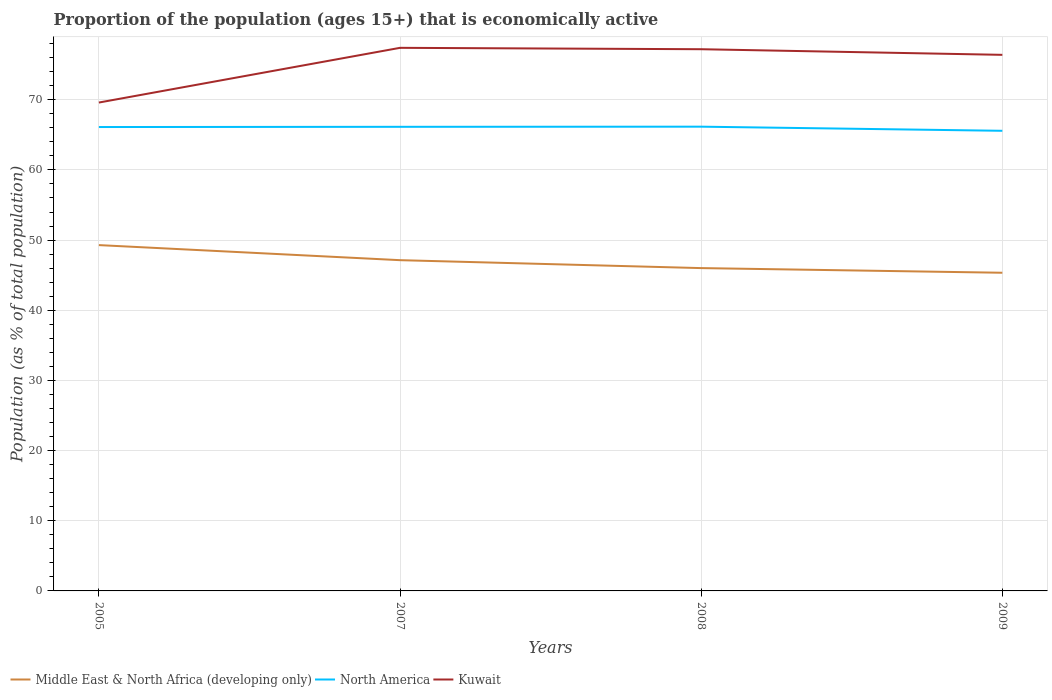How many different coloured lines are there?
Your answer should be very brief. 3. Across all years, what is the maximum proportion of the population that is economically active in Kuwait?
Give a very brief answer. 69.6. What is the total proportion of the population that is economically active in Kuwait in the graph?
Your answer should be very brief. -7.6. What is the difference between the highest and the second highest proportion of the population that is economically active in North America?
Give a very brief answer. 0.59. What is the difference between the highest and the lowest proportion of the population that is economically active in North America?
Offer a terse response. 3. How many lines are there?
Your answer should be compact. 3. How many years are there in the graph?
Offer a terse response. 4. What is the difference between two consecutive major ticks on the Y-axis?
Your response must be concise. 10. Does the graph contain grids?
Your answer should be very brief. Yes. Where does the legend appear in the graph?
Give a very brief answer. Bottom left. How many legend labels are there?
Your answer should be very brief. 3. How are the legend labels stacked?
Your answer should be compact. Horizontal. What is the title of the graph?
Keep it short and to the point. Proportion of the population (ages 15+) that is economically active. Does "Caribbean small states" appear as one of the legend labels in the graph?
Offer a very short reply. No. What is the label or title of the Y-axis?
Offer a very short reply. Population (as % of total population). What is the Population (as % of total population) in Middle East & North Africa (developing only) in 2005?
Make the answer very short. 49.28. What is the Population (as % of total population) in North America in 2005?
Make the answer very short. 66.11. What is the Population (as % of total population) of Kuwait in 2005?
Your answer should be compact. 69.6. What is the Population (as % of total population) in Middle East & North Africa (developing only) in 2007?
Offer a terse response. 47.14. What is the Population (as % of total population) in North America in 2007?
Provide a succinct answer. 66.14. What is the Population (as % of total population) of Kuwait in 2007?
Your answer should be compact. 77.4. What is the Population (as % of total population) of Middle East & North Africa (developing only) in 2008?
Your response must be concise. 46.01. What is the Population (as % of total population) of North America in 2008?
Provide a short and direct response. 66.16. What is the Population (as % of total population) of Kuwait in 2008?
Your answer should be compact. 77.2. What is the Population (as % of total population) of Middle East & North Africa (developing only) in 2009?
Provide a succinct answer. 45.34. What is the Population (as % of total population) in North America in 2009?
Give a very brief answer. 65.57. What is the Population (as % of total population) in Kuwait in 2009?
Offer a very short reply. 76.4. Across all years, what is the maximum Population (as % of total population) of Middle East & North Africa (developing only)?
Your response must be concise. 49.28. Across all years, what is the maximum Population (as % of total population) in North America?
Keep it short and to the point. 66.16. Across all years, what is the maximum Population (as % of total population) in Kuwait?
Provide a succinct answer. 77.4. Across all years, what is the minimum Population (as % of total population) of Middle East & North Africa (developing only)?
Provide a succinct answer. 45.34. Across all years, what is the minimum Population (as % of total population) of North America?
Your response must be concise. 65.57. Across all years, what is the minimum Population (as % of total population) of Kuwait?
Provide a short and direct response. 69.6. What is the total Population (as % of total population) of Middle East & North Africa (developing only) in the graph?
Make the answer very short. 187.77. What is the total Population (as % of total population) in North America in the graph?
Keep it short and to the point. 263.99. What is the total Population (as % of total population) of Kuwait in the graph?
Offer a very short reply. 300.6. What is the difference between the Population (as % of total population) in Middle East & North Africa (developing only) in 2005 and that in 2007?
Offer a terse response. 2.15. What is the difference between the Population (as % of total population) in North America in 2005 and that in 2007?
Make the answer very short. -0.03. What is the difference between the Population (as % of total population) of Middle East & North Africa (developing only) in 2005 and that in 2008?
Ensure brevity in your answer.  3.28. What is the difference between the Population (as % of total population) in North America in 2005 and that in 2008?
Offer a very short reply. -0.05. What is the difference between the Population (as % of total population) of Middle East & North Africa (developing only) in 2005 and that in 2009?
Your answer should be very brief. 3.94. What is the difference between the Population (as % of total population) in North America in 2005 and that in 2009?
Ensure brevity in your answer.  0.54. What is the difference between the Population (as % of total population) of Kuwait in 2005 and that in 2009?
Provide a short and direct response. -6.8. What is the difference between the Population (as % of total population) of Middle East & North Africa (developing only) in 2007 and that in 2008?
Give a very brief answer. 1.13. What is the difference between the Population (as % of total population) in North America in 2007 and that in 2008?
Provide a short and direct response. -0.02. What is the difference between the Population (as % of total population) in Kuwait in 2007 and that in 2008?
Your answer should be very brief. 0.2. What is the difference between the Population (as % of total population) in Middle East & North Africa (developing only) in 2007 and that in 2009?
Provide a succinct answer. 1.79. What is the difference between the Population (as % of total population) in North America in 2007 and that in 2009?
Offer a very short reply. 0.57. What is the difference between the Population (as % of total population) in Middle East & North Africa (developing only) in 2008 and that in 2009?
Your answer should be very brief. 0.66. What is the difference between the Population (as % of total population) in North America in 2008 and that in 2009?
Provide a short and direct response. 0.59. What is the difference between the Population (as % of total population) of Middle East & North Africa (developing only) in 2005 and the Population (as % of total population) of North America in 2007?
Offer a very short reply. -16.86. What is the difference between the Population (as % of total population) in Middle East & North Africa (developing only) in 2005 and the Population (as % of total population) in Kuwait in 2007?
Make the answer very short. -28.12. What is the difference between the Population (as % of total population) in North America in 2005 and the Population (as % of total population) in Kuwait in 2007?
Offer a very short reply. -11.29. What is the difference between the Population (as % of total population) in Middle East & North Africa (developing only) in 2005 and the Population (as % of total population) in North America in 2008?
Your answer should be compact. -16.88. What is the difference between the Population (as % of total population) in Middle East & North Africa (developing only) in 2005 and the Population (as % of total population) in Kuwait in 2008?
Your answer should be very brief. -27.92. What is the difference between the Population (as % of total population) of North America in 2005 and the Population (as % of total population) of Kuwait in 2008?
Your answer should be very brief. -11.09. What is the difference between the Population (as % of total population) of Middle East & North Africa (developing only) in 2005 and the Population (as % of total population) of North America in 2009?
Keep it short and to the point. -16.29. What is the difference between the Population (as % of total population) in Middle East & North Africa (developing only) in 2005 and the Population (as % of total population) in Kuwait in 2009?
Provide a short and direct response. -27.12. What is the difference between the Population (as % of total population) of North America in 2005 and the Population (as % of total population) of Kuwait in 2009?
Provide a succinct answer. -10.29. What is the difference between the Population (as % of total population) in Middle East & North Africa (developing only) in 2007 and the Population (as % of total population) in North America in 2008?
Give a very brief answer. -19.03. What is the difference between the Population (as % of total population) of Middle East & North Africa (developing only) in 2007 and the Population (as % of total population) of Kuwait in 2008?
Make the answer very short. -30.06. What is the difference between the Population (as % of total population) of North America in 2007 and the Population (as % of total population) of Kuwait in 2008?
Give a very brief answer. -11.06. What is the difference between the Population (as % of total population) in Middle East & North Africa (developing only) in 2007 and the Population (as % of total population) in North America in 2009?
Provide a short and direct response. -18.44. What is the difference between the Population (as % of total population) of Middle East & North Africa (developing only) in 2007 and the Population (as % of total population) of Kuwait in 2009?
Provide a succinct answer. -29.26. What is the difference between the Population (as % of total population) of North America in 2007 and the Population (as % of total population) of Kuwait in 2009?
Keep it short and to the point. -10.26. What is the difference between the Population (as % of total population) of Middle East & North Africa (developing only) in 2008 and the Population (as % of total population) of North America in 2009?
Provide a succinct answer. -19.57. What is the difference between the Population (as % of total population) of Middle East & North Africa (developing only) in 2008 and the Population (as % of total population) of Kuwait in 2009?
Your answer should be compact. -30.39. What is the difference between the Population (as % of total population) in North America in 2008 and the Population (as % of total population) in Kuwait in 2009?
Offer a very short reply. -10.24. What is the average Population (as % of total population) of Middle East & North Africa (developing only) per year?
Your answer should be compact. 46.94. What is the average Population (as % of total population) of North America per year?
Your response must be concise. 66. What is the average Population (as % of total population) in Kuwait per year?
Your response must be concise. 75.15. In the year 2005, what is the difference between the Population (as % of total population) in Middle East & North Africa (developing only) and Population (as % of total population) in North America?
Your answer should be compact. -16.83. In the year 2005, what is the difference between the Population (as % of total population) of Middle East & North Africa (developing only) and Population (as % of total population) of Kuwait?
Provide a succinct answer. -20.32. In the year 2005, what is the difference between the Population (as % of total population) of North America and Population (as % of total population) of Kuwait?
Your answer should be compact. -3.49. In the year 2007, what is the difference between the Population (as % of total population) of Middle East & North Africa (developing only) and Population (as % of total population) of North America?
Your response must be concise. -19.01. In the year 2007, what is the difference between the Population (as % of total population) of Middle East & North Africa (developing only) and Population (as % of total population) of Kuwait?
Ensure brevity in your answer.  -30.26. In the year 2007, what is the difference between the Population (as % of total population) of North America and Population (as % of total population) of Kuwait?
Your answer should be compact. -11.26. In the year 2008, what is the difference between the Population (as % of total population) in Middle East & North Africa (developing only) and Population (as % of total population) in North America?
Your answer should be compact. -20.16. In the year 2008, what is the difference between the Population (as % of total population) of Middle East & North Africa (developing only) and Population (as % of total population) of Kuwait?
Your answer should be compact. -31.19. In the year 2008, what is the difference between the Population (as % of total population) of North America and Population (as % of total population) of Kuwait?
Make the answer very short. -11.04. In the year 2009, what is the difference between the Population (as % of total population) in Middle East & North Africa (developing only) and Population (as % of total population) in North America?
Offer a terse response. -20.23. In the year 2009, what is the difference between the Population (as % of total population) in Middle East & North Africa (developing only) and Population (as % of total population) in Kuwait?
Ensure brevity in your answer.  -31.06. In the year 2009, what is the difference between the Population (as % of total population) of North America and Population (as % of total population) of Kuwait?
Give a very brief answer. -10.83. What is the ratio of the Population (as % of total population) in Middle East & North Africa (developing only) in 2005 to that in 2007?
Provide a succinct answer. 1.05. What is the ratio of the Population (as % of total population) of North America in 2005 to that in 2007?
Your answer should be compact. 1. What is the ratio of the Population (as % of total population) of Kuwait in 2005 to that in 2007?
Make the answer very short. 0.9. What is the ratio of the Population (as % of total population) of Middle East & North Africa (developing only) in 2005 to that in 2008?
Ensure brevity in your answer.  1.07. What is the ratio of the Population (as % of total population) in Kuwait in 2005 to that in 2008?
Offer a terse response. 0.9. What is the ratio of the Population (as % of total population) in Middle East & North Africa (developing only) in 2005 to that in 2009?
Make the answer very short. 1.09. What is the ratio of the Population (as % of total population) in North America in 2005 to that in 2009?
Your response must be concise. 1.01. What is the ratio of the Population (as % of total population) in Kuwait in 2005 to that in 2009?
Keep it short and to the point. 0.91. What is the ratio of the Population (as % of total population) of Middle East & North Africa (developing only) in 2007 to that in 2008?
Give a very brief answer. 1.02. What is the ratio of the Population (as % of total population) in North America in 2007 to that in 2008?
Provide a short and direct response. 1. What is the ratio of the Population (as % of total population) of Kuwait in 2007 to that in 2008?
Provide a short and direct response. 1. What is the ratio of the Population (as % of total population) of Middle East & North Africa (developing only) in 2007 to that in 2009?
Make the answer very short. 1.04. What is the ratio of the Population (as % of total population) in North America in 2007 to that in 2009?
Ensure brevity in your answer.  1.01. What is the ratio of the Population (as % of total population) of Kuwait in 2007 to that in 2009?
Provide a succinct answer. 1.01. What is the ratio of the Population (as % of total population) in Middle East & North Africa (developing only) in 2008 to that in 2009?
Offer a very short reply. 1.01. What is the ratio of the Population (as % of total population) in North America in 2008 to that in 2009?
Ensure brevity in your answer.  1.01. What is the ratio of the Population (as % of total population) of Kuwait in 2008 to that in 2009?
Provide a succinct answer. 1.01. What is the difference between the highest and the second highest Population (as % of total population) in Middle East & North Africa (developing only)?
Ensure brevity in your answer.  2.15. What is the difference between the highest and the second highest Population (as % of total population) of North America?
Provide a short and direct response. 0.02. What is the difference between the highest and the second highest Population (as % of total population) in Kuwait?
Keep it short and to the point. 0.2. What is the difference between the highest and the lowest Population (as % of total population) in Middle East & North Africa (developing only)?
Make the answer very short. 3.94. What is the difference between the highest and the lowest Population (as % of total population) in North America?
Provide a short and direct response. 0.59. What is the difference between the highest and the lowest Population (as % of total population) of Kuwait?
Provide a short and direct response. 7.8. 